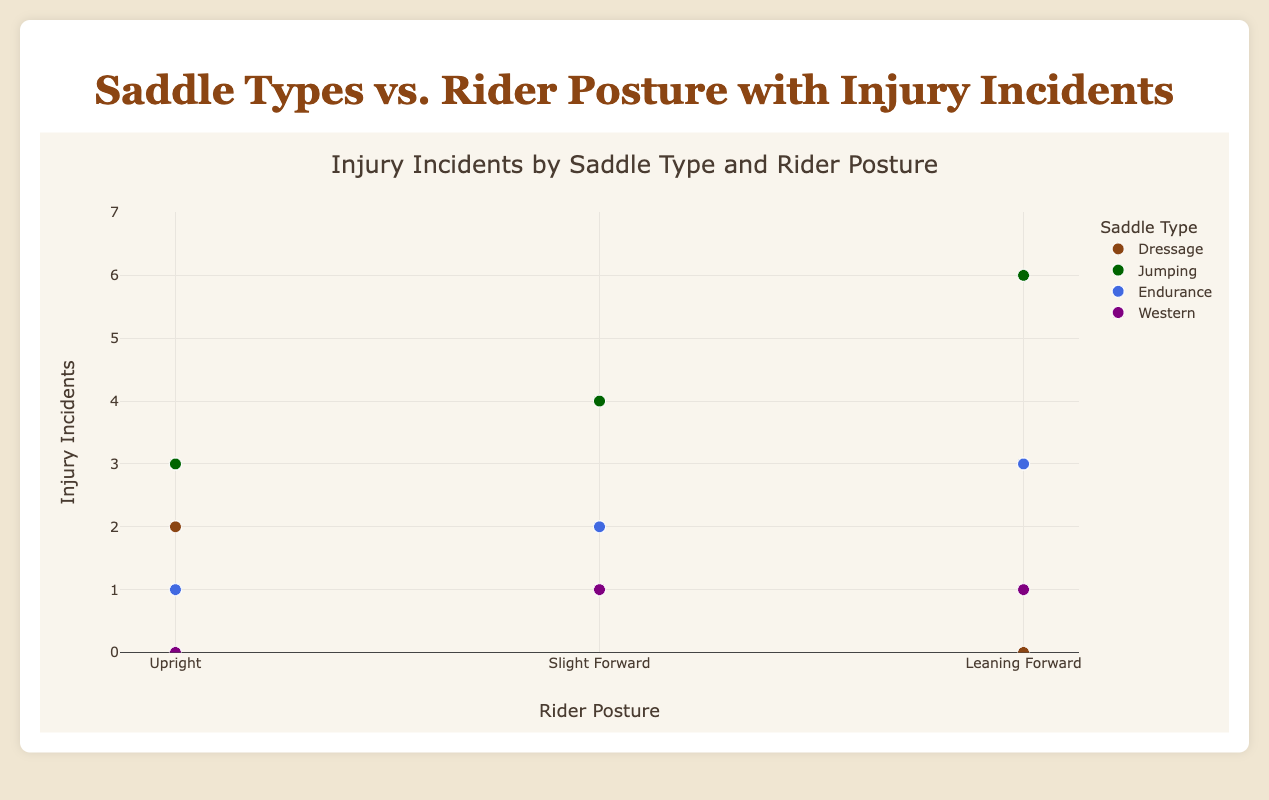What is the title of the figure? The title is usually displayed at the top of the figure. In this case, it is "Injury Incidents by Saddle Type and Rider Posture."
Answer: Injury Incidents by Saddle Type and Rider Posture How many different rider postures are presented in the figure? The x-axis categorizes the rider postures, which includes "Upright," "Slight Forward," and "Leaning Forward."
Answer: 3 Which saddle type has the highest number of injury incidents when the rider posture is "Leaning Forward"? To answer this, check each data point where the rider posture is "Leaning Forward" and compare their values on the y-axis. "Jumping" reaches 6 injury incidents.
Answer: Jumping How many injury incidents are associated with "Western" saddles when the rider posture is "Upright"? Identify the data points for "Western" saddles and look at the point where the rider posture is "Upright." The value on the y-axis for this data point is 0.
Answer: 0 Which rider had the lowest number of injury incidents with the "Dressage" saddle type? Review the "Dressage" saddle type points on the plot, checking for the lowest y-axis value. "RiderC" with a "Leaning Forward" posture has 0 incidents.
Answer: RiderC Compare the total number of injury incidents for "Jumping" and "Western" saddle types. Which one has more? Sum the injury incidents for all rider postures for "Jumping" (3 + 4 + 6) = 13 and "Western" (0 + 1 + 1) = 2. "Jumping" has more incidents.
Answer: Jumping How does the pattern of injury incidents change for "Endurance" saddles across different rider postures? For "Endurance" saddles, check the y-axis values: "Upright" (1), "Slight Forward" (2), "Leaning Forward" (3). The incidents increase as the posture leans more forward.
Answer: Increase What is the average number of injury incidents for "Dressage" saddle type across all postures? Sum the injury incidents for "Dressage" (2 + 1 + 0) = 3 and divide by the number of postures (3). The average is 3/3 = 1.
Answer: 1 Between which saddle types do the injury incidents show maximum variability for "Slight Forward" rider posture? Compare "Slight Forward" values for each saddle type: "Dressage" (1), "Jumping" (4), "Endurance" (2), "Western" (1). The highest difference is between "Dressage" and "Jumping" or "Western" and "Jumping."
Answer: Dressage and Jumping or Western and Jumping Which combination of saddle type and rider posture is associated with zero injury incidents? Identify data points with zero y-axis value and note the corresponding saddle type and rider posture. "Dressage" with "Leaning Forward" and "Western" with "Upright" both qualify.
Answer: Dressage with Leaning Forward or Western with Upright 